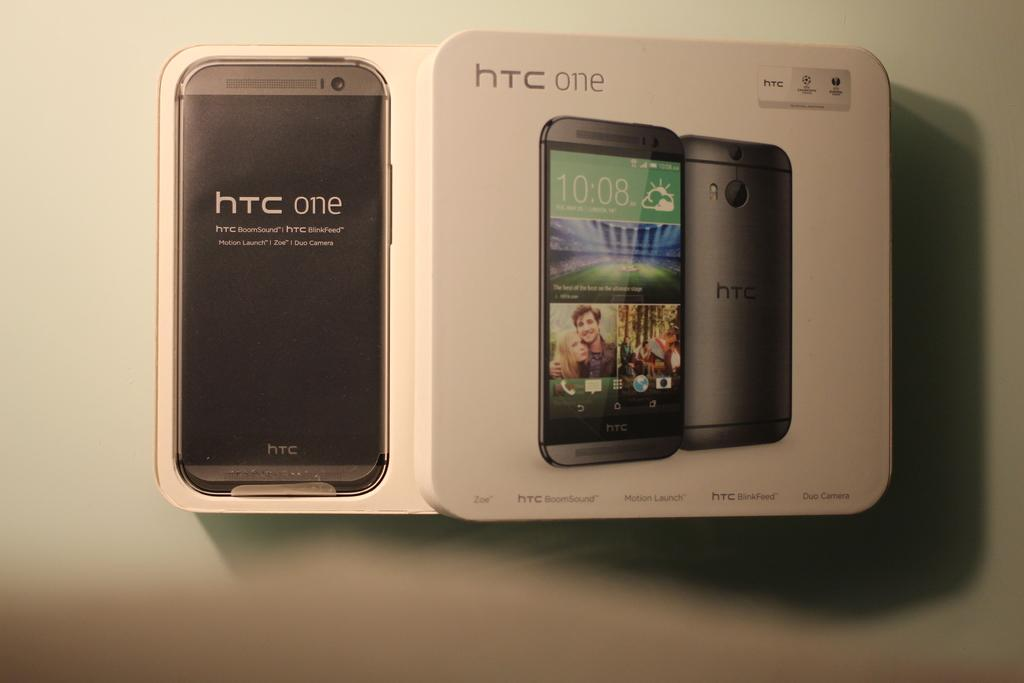<image>
Provide a brief description of the given image. A box containing an HTC One cell phone that is opened and displaying the product inside. 